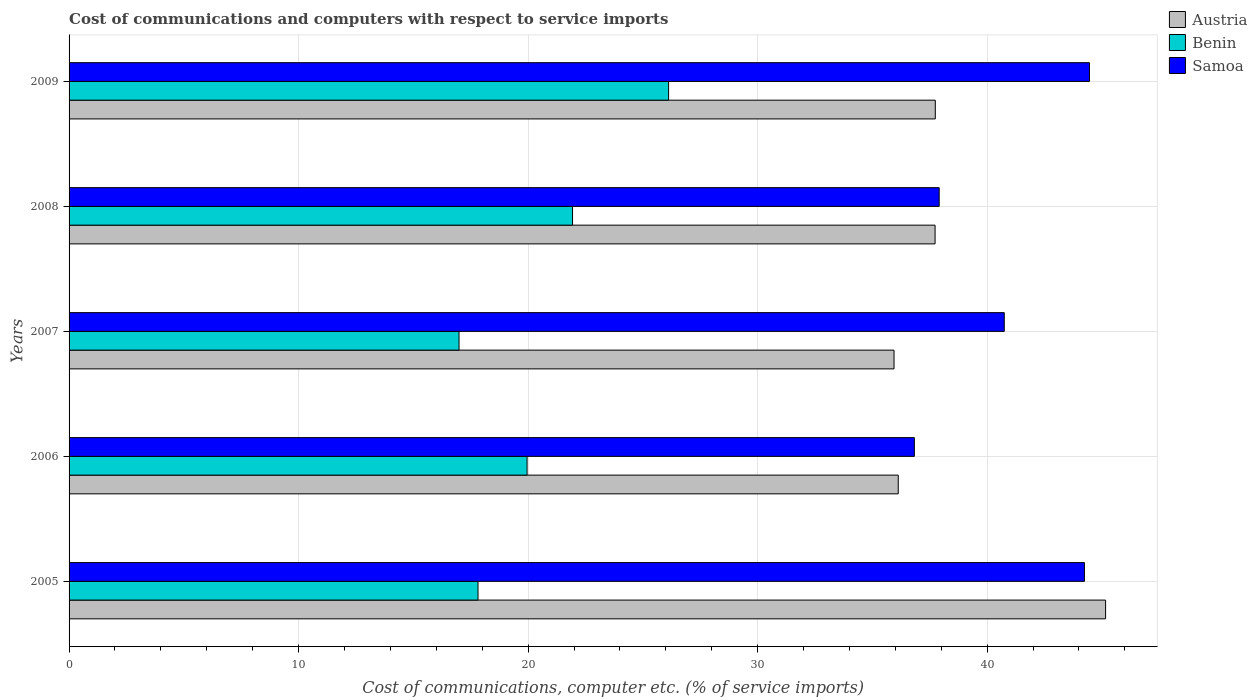How many different coloured bars are there?
Provide a succinct answer. 3. How many groups of bars are there?
Provide a succinct answer. 5. How many bars are there on the 3rd tick from the top?
Keep it short and to the point. 3. What is the label of the 3rd group of bars from the top?
Your answer should be compact. 2007. In how many cases, is the number of bars for a given year not equal to the number of legend labels?
Offer a very short reply. 0. What is the cost of communications and computers in Benin in 2009?
Make the answer very short. 26.12. Across all years, what is the maximum cost of communications and computers in Samoa?
Your response must be concise. 44.46. Across all years, what is the minimum cost of communications and computers in Austria?
Offer a terse response. 35.94. In which year was the cost of communications and computers in Austria maximum?
Your answer should be compact. 2005. What is the total cost of communications and computers in Samoa in the graph?
Provide a short and direct response. 204.18. What is the difference between the cost of communications and computers in Samoa in 2006 and that in 2007?
Provide a succinct answer. -3.92. What is the difference between the cost of communications and computers in Austria in 2009 and the cost of communications and computers in Samoa in 2008?
Your answer should be very brief. -0.17. What is the average cost of communications and computers in Samoa per year?
Your response must be concise. 40.84. In the year 2005, what is the difference between the cost of communications and computers in Austria and cost of communications and computers in Benin?
Your response must be concise. 27.34. What is the ratio of the cost of communications and computers in Samoa in 2008 to that in 2009?
Give a very brief answer. 0.85. Is the cost of communications and computers in Samoa in 2005 less than that in 2007?
Offer a terse response. No. Is the difference between the cost of communications and computers in Austria in 2005 and 2009 greater than the difference between the cost of communications and computers in Benin in 2005 and 2009?
Your answer should be compact. Yes. What is the difference between the highest and the second highest cost of communications and computers in Samoa?
Keep it short and to the point. 0.22. What is the difference between the highest and the lowest cost of communications and computers in Benin?
Offer a very short reply. 9.13. In how many years, is the cost of communications and computers in Benin greater than the average cost of communications and computers in Benin taken over all years?
Offer a very short reply. 2. Is the sum of the cost of communications and computers in Benin in 2007 and 2009 greater than the maximum cost of communications and computers in Samoa across all years?
Ensure brevity in your answer.  No. What does the 2nd bar from the top in 2006 represents?
Keep it short and to the point. Benin. What does the 2nd bar from the bottom in 2006 represents?
Your response must be concise. Benin. Is it the case that in every year, the sum of the cost of communications and computers in Benin and cost of communications and computers in Samoa is greater than the cost of communications and computers in Austria?
Make the answer very short. Yes. Are all the bars in the graph horizontal?
Provide a succinct answer. Yes. How many years are there in the graph?
Offer a terse response. 5. Are the values on the major ticks of X-axis written in scientific E-notation?
Provide a succinct answer. No. Where does the legend appear in the graph?
Ensure brevity in your answer.  Top right. How are the legend labels stacked?
Make the answer very short. Vertical. What is the title of the graph?
Provide a short and direct response. Cost of communications and computers with respect to service imports. Does "St. Martin (French part)" appear as one of the legend labels in the graph?
Offer a terse response. No. What is the label or title of the X-axis?
Offer a terse response. Cost of communications, computer etc. (% of service imports). What is the label or title of the Y-axis?
Keep it short and to the point. Years. What is the Cost of communications, computer etc. (% of service imports) in Austria in 2005?
Offer a very short reply. 45.16. What is the Cost of communications, computer etc. (% of service imports) of Benin in 2005?
Give a very brief answer. 17.82. What is the Cost of communications, computer etc. (% of service imports) in Samoa in 2005?
Provide a short and direct response. 44.24. What is the Cost of communications, computer etc. (% of service imports) of Austria in 2006?
Make the answer very short. 36.13. What is the Cost of communications, computer etc. (% of service imports) in Benin in 2006?
Ensure brevity in your answer.  19.96. What is the Cost of communications, computer etc. (% of service imports) of Samoa in 2006?
Your answer should be compact. 36.83. What is the Cost of communications, computer etc. (% of service imports) of Austria in 2007?
Offer a terse response. 35.94. What is the Cost of communications, computer etc. (% of service imports) of Benin in 2007?
Your answer should be compact. 16.99. What is the Cost of communications, computer etc. (% of service imports) in Samoa in 2007?
Keep it short and to the point. 40.75. What is the Cost of communications, computer etc. (% of service imports) of Austria in 2008?
Offer a terse response. 37.73. What is the Cost of communications, computer etc. (% of service imports) in Benin in 2008?
Your response must be concise. 21.94. What is the Cost of communications, computer etc. (% of service imports) in Samoa in 2008?
Offer a very short reply. 37.91. What is the Cost of communications, computer etc. (% of service imports) of Austria in 2009?
Give a very brief answer. 37.74. What is the Cost of communications, computer etc. (% of service imports) of Benin in 2009?
Provide a succinct answer. 26.12. What is the Cost of communications, computer etc. (% of service imports) of Samoa in 2009?
Provide a short and direct response. 44.46. Across all years, what is the maximum Cost of communications, computer etc. (% of service imports) in Austria?
Ensure brevity in your answer.  45.16. Across all years, what is the maximum Cost of communications, computer etc. (% of service imports) in Benin?
Your answer should be compact. 26.12. Across all years, what is the maximum Cost of communications, computer etc. (% of service imports) in Samoa?
Keep it short and to the point. 44.46. Across all years, what is the minimum Cost of communications, computer etc. (% of service imports) in Austria?
Keep it short and to the point. 35.94. Across all years, what is the minimum Cost of communications, computer etc. (% of service imports) of Benin?
Your answer should be very brief. 16.99. Across all years, what is the minimum Cost of communications, computer etc. (% of service imports) in Samoa?
Keep it short and to the point. 36.83. What is the total Cost of communications, computer etc. (% of service imports) of Austria in the graph?
Your answer should be very brief. 192.7. What is the total Cost of communications, computer etc. (% of service imports) of Benin in the graph?
Make the answer very short. 102.82. What is the total Cost of communications, computer etc. (% of service imports) of Samoa in the graph?
Provide a succinct answer. 204.18. What is the difference between the Cost of communications, computer etc. (% of service imports) of Austria in 2005 and that in 2006?
Keep it short and to the point. 9.03. What is the difference between the Cost of communications, computer etc. (% of service imports) of Benin in 2005 and that in 2006?
Offer a very short reply. -2.14. What is the difference between the Cost of communications, computer etc. (% of service imports) of Samoa in 2005 and that in 2006?
Provide a succinct answer. 7.41. What is the difference between the Cost of communications, computer etc. (% of service imports) of Austria in 2005 and that in 2007?
Make the answer very short. 9.22. What is the difference between the Cost of communications, computer etc. (% of service imports) in Benin in 2005 and that in 2007?
Your answer should be compact. 0.83. What is the difference between the Cost of communications, computer etc. (% of service imports) in Samoa in 2005 and that in 2007?
Offer a terse response. 3.49. What is the difference between the Cost of communications, computer etc. (% of service imports) in Austria in 2005 and that in 2008?
Your response must be concise. 7.43. What is the difference between the Cost of communications, computer etc. (% of service imports) of Benin in 2005 and that in 2008?
Keep it short and to the point. -4.12. What is the difference between the Cost of communications, computer etc. (% of service imports) of Samoa in 2005 and that in 2008?
Make the answer very short. 6.33. What is the difference between the Cost of communications, computer etc. (% of service imports) of Austria in 2005 and that in 2009?
Offer a terse response. 7.42. What is the difference between the Cost of communications, computer etc. (% of service imports) in Benin in 2005 and that in 2009?
Make the answer very short. -8.3. What is the difference between the Cost of communications, computer etc. (% of service imports) of Samoa in 2005 and that in 2009?
Your answer should be very brief. -0.22. What is the difference between the Cost of communications, computer etc. (% of service imports) in Austria in 2006 and that in 2007?
Offer a very short reply. 0.18. What is the difference between the Cost of communications, computer etc. (% of service imports) of Benin in 2006 and that in 2007?
Ensure brevity in your answer.  2.97. What is the difference between the Cost of communications, computer etc. (% of service imports) in Samoa in 2006 and that in 2007?
Offer a terse response. -3.92. What is the difference between the Cost of communications, computer etc. (% of service imports) of Austria in 2006 and that in 2008?
Offer a very short reply. -1.6. What is the difference between the Cost of communications, computer etc. (% of service imports) in Benin in 2006 and that in 2008?
Your response must be concise. -1.98. What is the difference between the Cost of communications, computer etc. (% of service imports) of Samoa in 2006 and that in 2008?
Provide a succinct answer. -1.08. What is the difference between the Cost of communications, computer etc. (% of service imports) of Austria in 2006 and that in 2009?
Your answer should be very brief. -1.61. What is the difference between the Cost of communications, computer etc. (% of service imports) in Benin in 2006 and that in 2009?
Give a very brief answer. -6.17. What is the difference between the Cost of communications, computer etc. (% of service imports) of Samoa in 2006 and that in 2009?
Ensure brevity in your answer.  -7.63. What is the difference between the Cost of communications, computer etc. (% of service imports) in Austria in 2007 and that in 2008?
Provide a succinct answer. -1.79. What is the difference between the Cost of communications, computer etc. (% of service imports) of Benin in 2007 and that in 2008?
Offer a terse response. -4.95. What is the difference between the Cost of communications, computer etc. (% of service imports) of Samoa in 2007 and that in 2008?
Offer a very short reply. 2.84. What is the difference between the Cost of communications, computer etc. (% of service imports) in Austria in 2007 and that in 2009?
Your answer should be very brief. -1.8. What is the difference between the Cost of communications, computer etc. (% of service imports) of Benin in 2007 and that in 2009?
Offer a very short reply. -9.13. What is the difference between the Cost of communications, computer etc. (% of service imports) in Samoa in 2007 and that in 2009?
Provide a short and direct response. -3.71. What is the difference between the Cost of communications, computer etc. (% of service imports) in Austria in 2008 and that in 2009?
Ensure brevity in your answer.  -0.01. What is the difference between the Cost of communications, computer etc. (% of service imports) in Benin in 2008 and that in 2009?
Give a very brief answer. -4.18. What is the difference between the Cost of communications, computer etc. (% of service imports) in Samoa in 2008 and that in 2009?
Provide a short and direct response. -6.55. What is the difference between the Cost of communications, computer etc. (% of service imports) in Austria in 2005 and the Cost of communications, computer etc. (% of service imports) in Benin in 2006?
Your answer should be compact. 25.21. What is the difference between the Cost of communications, computer etc. (% of service imports) in Austria in 2005 and the Cost of communications, computer etc. (% of service imports) in Samoa in 2006?
Give a very brief answer. 8.33. What is the difference between the Cost of communications, computer etc. (% of service imports) of Benin in 2005 and the Cost of communications, computer etc. (% of service imports) of Samoa in 2006?
Make the answer very short. -19.01. What is the difference between the Cost of communications, computer etc. (% of service imports) of Austria in 2005 and the Cost of communications, computer etc. (% of service imports) of Benin in 2007?
Your answer should be very brief. 28.17. What is the difference between the Cost of communications, computer etc. (% of service imports) in Austria in 2005 and the Cost of communications, computer etc. (% of service imports) in Samoa in 2007?
Offer a very short reply. 4.41. What is the difference between the Cost of communications, computer etc. (% of service imports) of Benin in 2005 and the Cost of communications, computer etc. (% of service imports) of Samoa in 2007?
Your answer should be very brief. -22.93. What is the difference between the Cost of communications, computer etc. (% of service imports) in Austria in 2005 and the Cost of communications, computer etc. (% of service imports) in Benin in 2008?
Provide a succinct answer. 23.22. What is the difference between the Cost of communications, computer etc. (% of service imports) in Austria in 2005 and the Cost of communications, computer etc. (% of service imports) in Samoa in 2008?
Ensure brevity in your answer.  7.25. What is the difference between the Cost of communications, computer etc. (% of service imports) in Benin in 2005 and the Cost of communications, computer etc. (% of service imports) in Samoa in 2008?
Keep it short and to the point. -20.09. What is the difference between the Cost of communications, computer etc. (% of service imports) of Austria in 2005 and the Cost of communications, computer etc. (% of service imports) of Benin in 2009?
Offer a very short reply. 19.04. What is the difference between the Cost of communications, computer etc. (% of service imports) in Austria in 2005 and the Cost of communications, computer etc. (% of service imports) in Samoa in 2009?
Provide a succinct answer. 0.7. What is the difference between the Cost of communications, computer etc. (% of service imports) of Benin in 2005 and the Cost of communications, computer etc. (% of service imports) of Samoa in 2009?
Your answer should be very brief. -26.64. What is the difference between the Cost of communications, computer etc. (% of service imports) in Austria in 2006 and the Cost of communications, computer etc. (% of service imports) in Benin in 2007?
Ensure brevity in your answer.  19.14. What is the difference between the Cost of communications, computer etc. (% of service imports) of Austria in 2006 and the Cost of communications, computer etc. (% of service imports) of Samoa in 2007?
Offer a terse response. -4.62. What is the difference between the Cost of communications, computer etc. (% of service imports) of Benin in 2006 and the Cost of communications, computer etc. (% of service imports) of Samoa in 2007?
Keep it short and to the point. -20.79. What is the difference between the Cost of communications, computer etc. (% of service imports) in Austria in 2006 and the Cost of communications, computer etc. (% of service imports) in Benin in 2008?
Offer a very short reply. 14.19. What is the difference between the Cost of communications, computer etc. (% of service imports) of Austria in 2006 and the Cost of communications, computer etc. (% of service imports) of Samoa in 2008?
Your answer should be very brief. -1.78. What is the difference between the Cost of communications, computer etc. (% of service imports) in Benin in 2006 and the Cost of communications, computer etc. (% of service imports) in Samoa in 2008?
Keep it short and to the point. -17.96. What is the difference between the Cost of communications, computer etc. (% of service imports) of Austria in 2006 and the Cost of communications, computer etc. (% of service imports) of Benin in 2009?
Your answer should be very brief. 10.01. What is the difference between the Cost of communications, computer etc. (% of service imports) of Austria in 2006 and the Cost of communications, computer etc. (% of service imports) of Samoa in 2009?
Provide a succinct answer. -8.33. What is the difference between the Cost of communications, computer etc. (% of service imports) of Benin in 2006 and the Cost of communications, computer etc. (% of service imports) of Samoa in 2009?
Offer a very short reply. -24.5. What is the difference between the Cost of communications, computer etc. (% of service imports) in Austria in 2007 and the Cost of communications, computer etc. (% of service imports) in Benin in 2008?
Give a very brief answer. 14.01. What is the difference between the Cost of communications, computer etc. (% of service imports) of Austria in 2007 and the Cost of communications, computer etc. (% of service imports) of Samoa in 2008?
Your answer should be very brief. -1.97. What is the difference between the Cost of communications, computer etc. (% of service imports) of Benin in 2007 and the Cost of communications, computer etc. (% of service imports) of Samoa in 2008?
Provide a succinct answer. -20.92. What is the difference between the Cost of communications, computer etc. (% of service imports) of Austria in 2007 and the Cost of communications, computer etc. (% of service imports) of Benin in 2009?
Make the answer very short. 9.82. What is the difference between the Cost of communications, computer etc. (% of service imports) in Austria in 2007 and the Cost of communications, computer etc. (% of service imports) in Samoa in 2009?
Provide a succinct answer. -8.51. What is the difference between the Cost of communications, computer etc. (% of service imports) in Benin in 2007 and the Cost of communications, computer etc. (% of service imports) in Samoa in 2009?
Offer a very short reply. -27.47. What is the difference between the Cost of communications, computer etc. (% of service imports) in Austria in 2008 and the Cost of communications, computer etc. (% of service imports) in Benin in 2009?
Make the answer very short. 11.61. What is the difference between the Cost of communications, computer etc. (% of service imports) in Austria in 2008 and the Cost of communications, computer etc. (% of service imports) in Samoa in 2009?
Offer a terse response. -6.73. What is the difference between the Cost of communications, computer etc. (% of service imports) of Benin in 2008 and the Cost of communications, computer etc. (% of service imports) of Samoa in 2009?
Your answer should be compact. -22.52. What is the average Cost of communications, computer etc. (% of service imports) in Austria per year?
Your answer should be compact. 38.54. What is the average Cost of communications, computer etc. (% of service imports) in Benin per year?
Keep it short and to the point. 20.56. What is the average Cost of communications, computer etc. (% of service imports) in Samoa per year?
Offer a very short reply. 40.84. In the year 2005, what is the difference between the Cost of communications, computer etc. (% of service imports) of Austria and Cost of communications, computer etc. (% of service imports) of Benin?
Provide a succinct answer. 27.34. In the year 2005, what is the difference between the Cost of communications, computer etc. (% of service imports) in Austria and Cost of communications, computer etc. (% of service imports) in Samoa?
Your response must be concise. 0.92. In the year 2005, what is the difference between the Cost of communications, computer etc. (% of service imports) of Benin and Cost of communications, computer etc. (% of service imports) of Samoa?
Provide a short and direct response. -26.42. In the year 2006, what is the difference between the Cost of communications, computer etc. (% of service imports) in Austria and Cost of communications, computer etc. (% of service imports) in Benin?
Your answer should be very brief. 16.17. In the year 2006, what is the difference between the Cost of communications, computer etc. (% of service imports) of Austria and Cost of communications, computer etc. (% of service imports) of Samoa?
Give a very brief answer. -0.7. In the year 2006, what is the difference between the Cost of communications, computer etc. (% of service imports) in Benin and Cost of communications, computer etc. (% of service imports) in Samoa?
Provide a succinct answer. -16.87. In the year 2007, what is the difference between the Cost of communications, computer etc. (% of service imports) in Austria and Cost of communications, computer etc. (% of service imports) in Benin?
Offer a very short reply. 18.95. In the year 2007, what is the difference between the Cost of communications, computer etc. (% of service imports) of Austria and Cost of communications, computer etc. (% of service imports) of Samoa?
Your response must be concise. -4.8. In the year 2007, what is the difference between the Cost of communications, computer etc. (% of service imports) in Benin and Cost of communications, computer etc. (% of service imports) in Samoa?
Give a very brief answer. -23.76. In the year 2008, what is the difference between the Cost of communications, computer etc. (% of service imports) of Austria and Cost of communications, computer etc. (% of service imports) of Benin?
Ensure brevity in your answer.  15.8. In the year 2008, what is the difference between the Cost of communications, computer etc. (% of service imports) in Austria and Cost of communications, computer etc. (% of service imports) in Samoa?
Make the answer very short. -0.18. In the year 2008, what is the difference between the Cost of communications, computer etc. (% of service imports) in Benin and Cost of communications, computer etc. (% of service imports) in Samoa?
Give a very brief answer. -15.97. In the year 2009, what is the difference between the Cost of communications, computer etc. (% of service imports) in Austria and Cost of communications, computer etc. (% of service imports) in Benin?
Offer a terse response. 11.62. In the year 2009, what is the difference between the Cost of communications, computer etc. (% of service imports) of Austria and Cost of communications, computer etc. (% of service imports) of Samoa?
Your answer should be very brief. -6.72. In the year 2009, what is the difference between the Cost of communications, computer etc. (% of service imports) in Benin and Cost of communications, computer etc. (% of service imports) in Samoa?
Provide a short and direct response. -18.34. What is the ratio of the Cost of communications, computer etc. (% of service imports) of Austria in 2005 to that in 2006?
Make the answer very short. 1.25. What is the ratio of the Cost of communications, computer etc. (% of service imports) in Benin in 2005 to that in 2006?
Offer a very short reply. 0.89. What is the ratio of the Cost of communications, computer etc. (% of service imports) in Samoa in 2005 to that in 2006?
Offer a very short reply. 1.2. What is the ratio of the Cost of communications, computer etc. (% of service imports) in Austria in 2005 to that in 2007?
Ensure brevity in your answer.  1.26. What is the ratio of the Cost of communications, computer etc. (% of service imports) in Benin in 2005 to that in 2007?
Provide a succinct answer. 1.05. What is the ratio of the Cost of communications, computer etc. (% of service imports) in Samoa in 2005 to that in 2007?
Your answer should be compact. 1.09. What is the ratio of the Cost of communications, computer etc. (% of service imports) in Austria in 2005 to that in 2008?
Provide a short and direct response. 1.2. What is the ratio of the Cost of communications, computer etc. (% of service imports) in Benin in 2005 to that in 2008?
Give a very brief answer. 0.81. What is the ratio of the Cost of communications, computer etc. (% of service imports) in Samoa in 2005 to that in 2008?
Make the answer very short. 1.17. What is the ratio of the Cost of communications, computer etc. (% of service imports) of Austria in 2005 to that in 2009?
Keep it short and to the point. 1.2. What is the ratio of the Cost of communications, computer etc. (% of service imports) in Benin in 2005 to that in 2009?
Make the answer very short. 0.68. What is the ratio of the Cost of communications, computer etc. (% of service imports) in Benin in 2006 to that in 2007?
Provide a short and direct response. 1.17. What is the ratio of the Cost of communications, computer etc. (% of service imports) in Samoa in 2006 to that in 2007?
Provide a short and direct response. 0.9. What is the ratio of the Cost of communications, computer etc. (% of service imports) in Austria in 2006 to that in 2008?
Give a very brief answer. 0.96. What is the ratio of the Cost of communications, computer etc. (% of service imports) of Benin in 2006 to that in 2008?
Provide a short and direct response. 0.91. What is the ratio of the Cost of communications, computer etc. (% of service imports) of Samoa in 2006 to that in 2008?
Your response must be concise. 0.97. What is the ratio of the Cost of communications, computer etc. (% of service imports) in Austria in 2006 to that in 2009?
Offer a terse response. 0.96. What is the ratio of the Cost of communications, computer etc. (% of service imports) of Benin in 2006 to that in 2009?
Provide a succinct answer. 0.76. What is the ratio of the Cost of communications, computer etc. (% of service imports) in Samoa in 2006 to that in 2009?
Your response must be concise. 0.83. What is the ratio of the Cost of communications, computer etc. (% of service imports) of Austria in 2007 to that in 2008?
Your response must be concise. 0.95. What is the ratio of the Cost of communications, computer etc. (% of service imports) in Benin in 2007 to that in 2008?
Keep it short and to the point. 0.77. What is the ratio of the Cost of communications, computer etc. (% of service imports) of Samoa in 2007 to that in 2008?
Your response must be concise. 1.07. What is the ratio of the Cost of communications, computer etc. (% of service imports) of Austria in 2007 to that in 2009?
Ensure brevity in your answer.  0.95. What is the ratio of the Cost of communications, computer etc. (% of service imports) in Benin in 2007 to that in 2009?
Offer a terse response. 0.65. What is the ratio of the Cost of communications, computer etc. (% of service imports) of Samoa in 2007 to that in 2009?
Provide a succinct answer. 0.92. What is the ratio of the Cost of communications, computer etc. (% of service imports) of Benin in 2008 to that in 2009?
Keep it short and to the point. 0.84. What is the ratio of the Cost of communications, computer etc. (% of service imports) of Samoa in 2008 to that in 2009?
Make the answer very short. 0.85. What is the difference between the highest and the second highest Cost of communications, computer etc. (% of service imports) in Austria?
Make the answer very short. 7.42. What is the difference between the highest and the second highest Cost of communications, computer etc. (% of service imports) in Benin?
Your answer should be very brief. 4.18. What is the difference between the highest and the second highest Cost of communications, computer etc. (% of service imports) in Samoa?
Your response must be concise. 0.22. What is the difference between the highest and the lowest Cost of communications, computer etc. (% of service imports) of Austria?
Your response must be concise. 9.22. What is the difference between the highest and the lowest Cost of communications, computer etc. (% of service imports) of Benin?
Keep it short and to the point. 9.13. What is the difference between the highest and the lowest Cost of communications, computer etc. (% of service imports) in Samoa?
Your response must be concise. 7.63. 